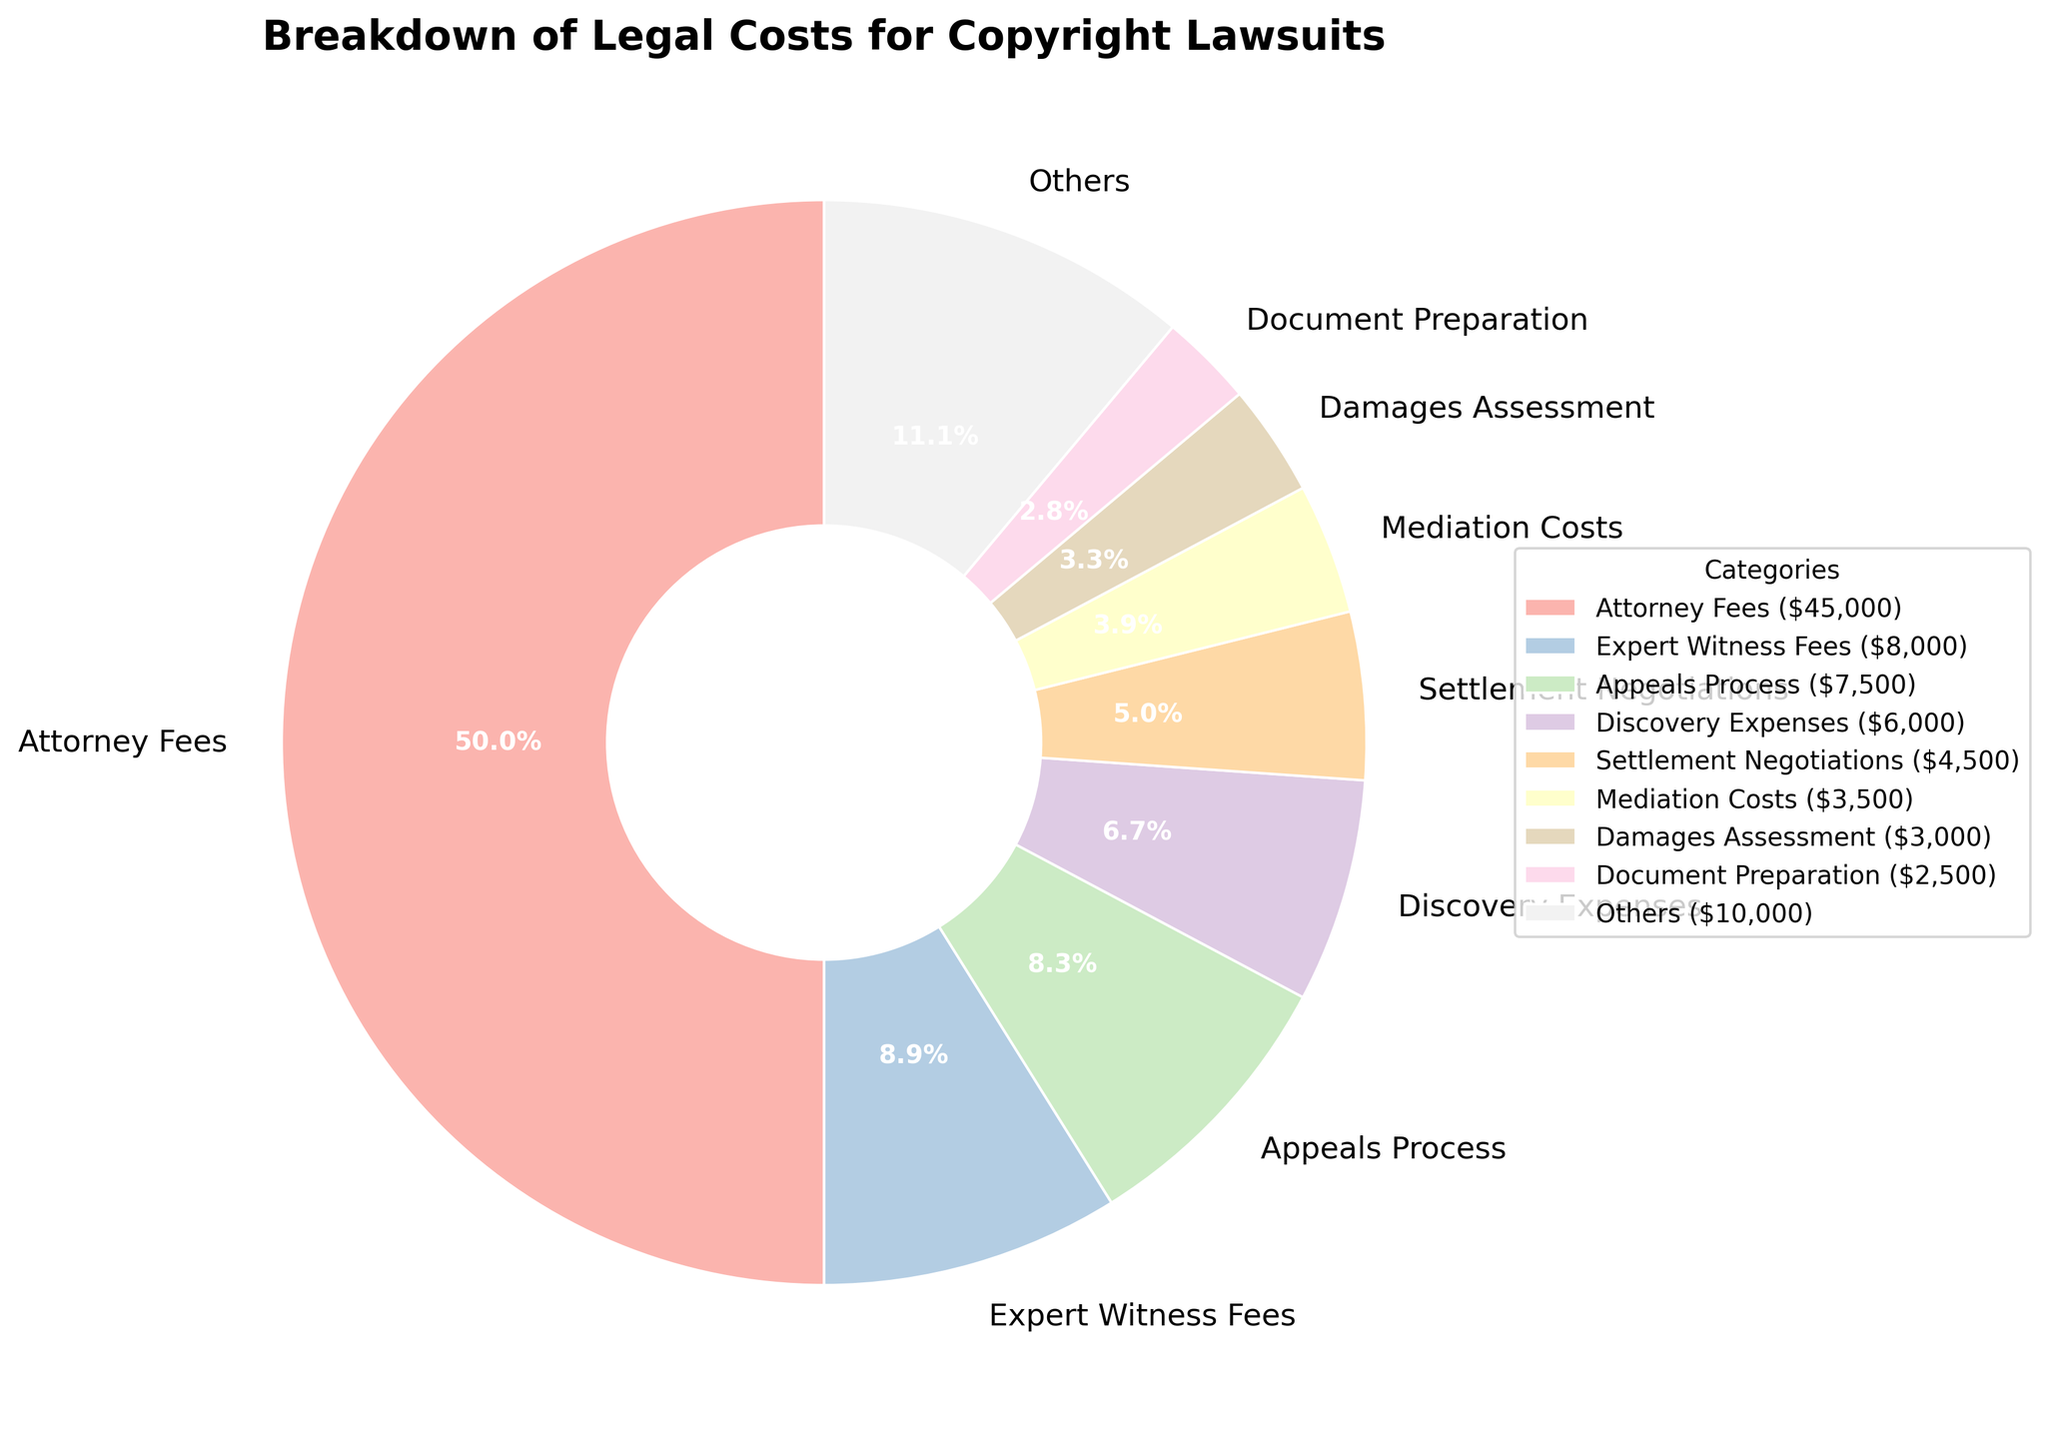What is the category with the highest legal cost percentage? To find the category with the highest legal cost percentage, look at the pie chart segments and their labels. Identify the segment with the largest percentage label.
Answer: Attorney Fees What is the combined percentage for the categories 'Attorney Fees' and 'Court Filing Fees'? Locate the percentages for 'Attorney Fees' and 'Court Filing Fees' segments on the pie chart. Sum the two percentages to obtain the combined percentage.
Answer: 67.0% Which category has a larger legal cost percentage, 'Mediation Costs' or 'Discovery Expenses'? Check the pie chart for the segments labeled 'Mediation Costs' and 'Discovery Expenses' and compare their percentages.
Answer: Discovery Expenses By how much does 'Appeals Process' surpass 'Infringement Analysis' in terms of percentage? Find the percentage for both 'Appeals Process' and 'Infringement Analysis' from the pie chart. Subtract the percentage of 'Infringement Analysis' from 'Appeals Process'.
Answer: 7.5% What is the percentage of the 'Others' category in the legal cost breakdown? Identify the segment labeled 'Others' in the pie chart and note its percentage.
Answer: 16.3% Which segment has a percentage closest to 'Licensing Research'? Look for the percentage of 'Licensing Research' in the pie chart and then identify the segment with the nearest percentage to it.
Answer: Court Filing Fees What is the total percentage of the top two categories combined? Identify the top two categories by their segments on the pie chart. Sum their percentages to find the total combined percentage.
Answer: 62.8% How does the percentage of 'Document Preparation' compare to 'Expert Witness Fees'? Find the percentages of 'Document Preparation' and 'Expert Witness Fees' on the pie chart. Compare the two values to determine which is higher.
Answer: Expert Witness Fees What color represents 'Settlement Negotiations' and what is its percentage? Examine the pie chart to find the segment associated with 'Settlement Negotiations'. Note the color and corresponding percentage of this segment.
Answer: Pastel color, 4.5% Is the percentage of legal costs for 'Travel Expenses' greater than for 'Appeals Process'? Find the segments for 'Travel Expenses' and 'Appeals Process' on the pie chart. Compare their percentages to determine if 'Travel Expenses' is higher.
Answer: No 